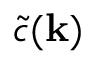<formula> <loc_0><loc_0><loc_500><loc_500>\tilde { c } ( k )</formula> 